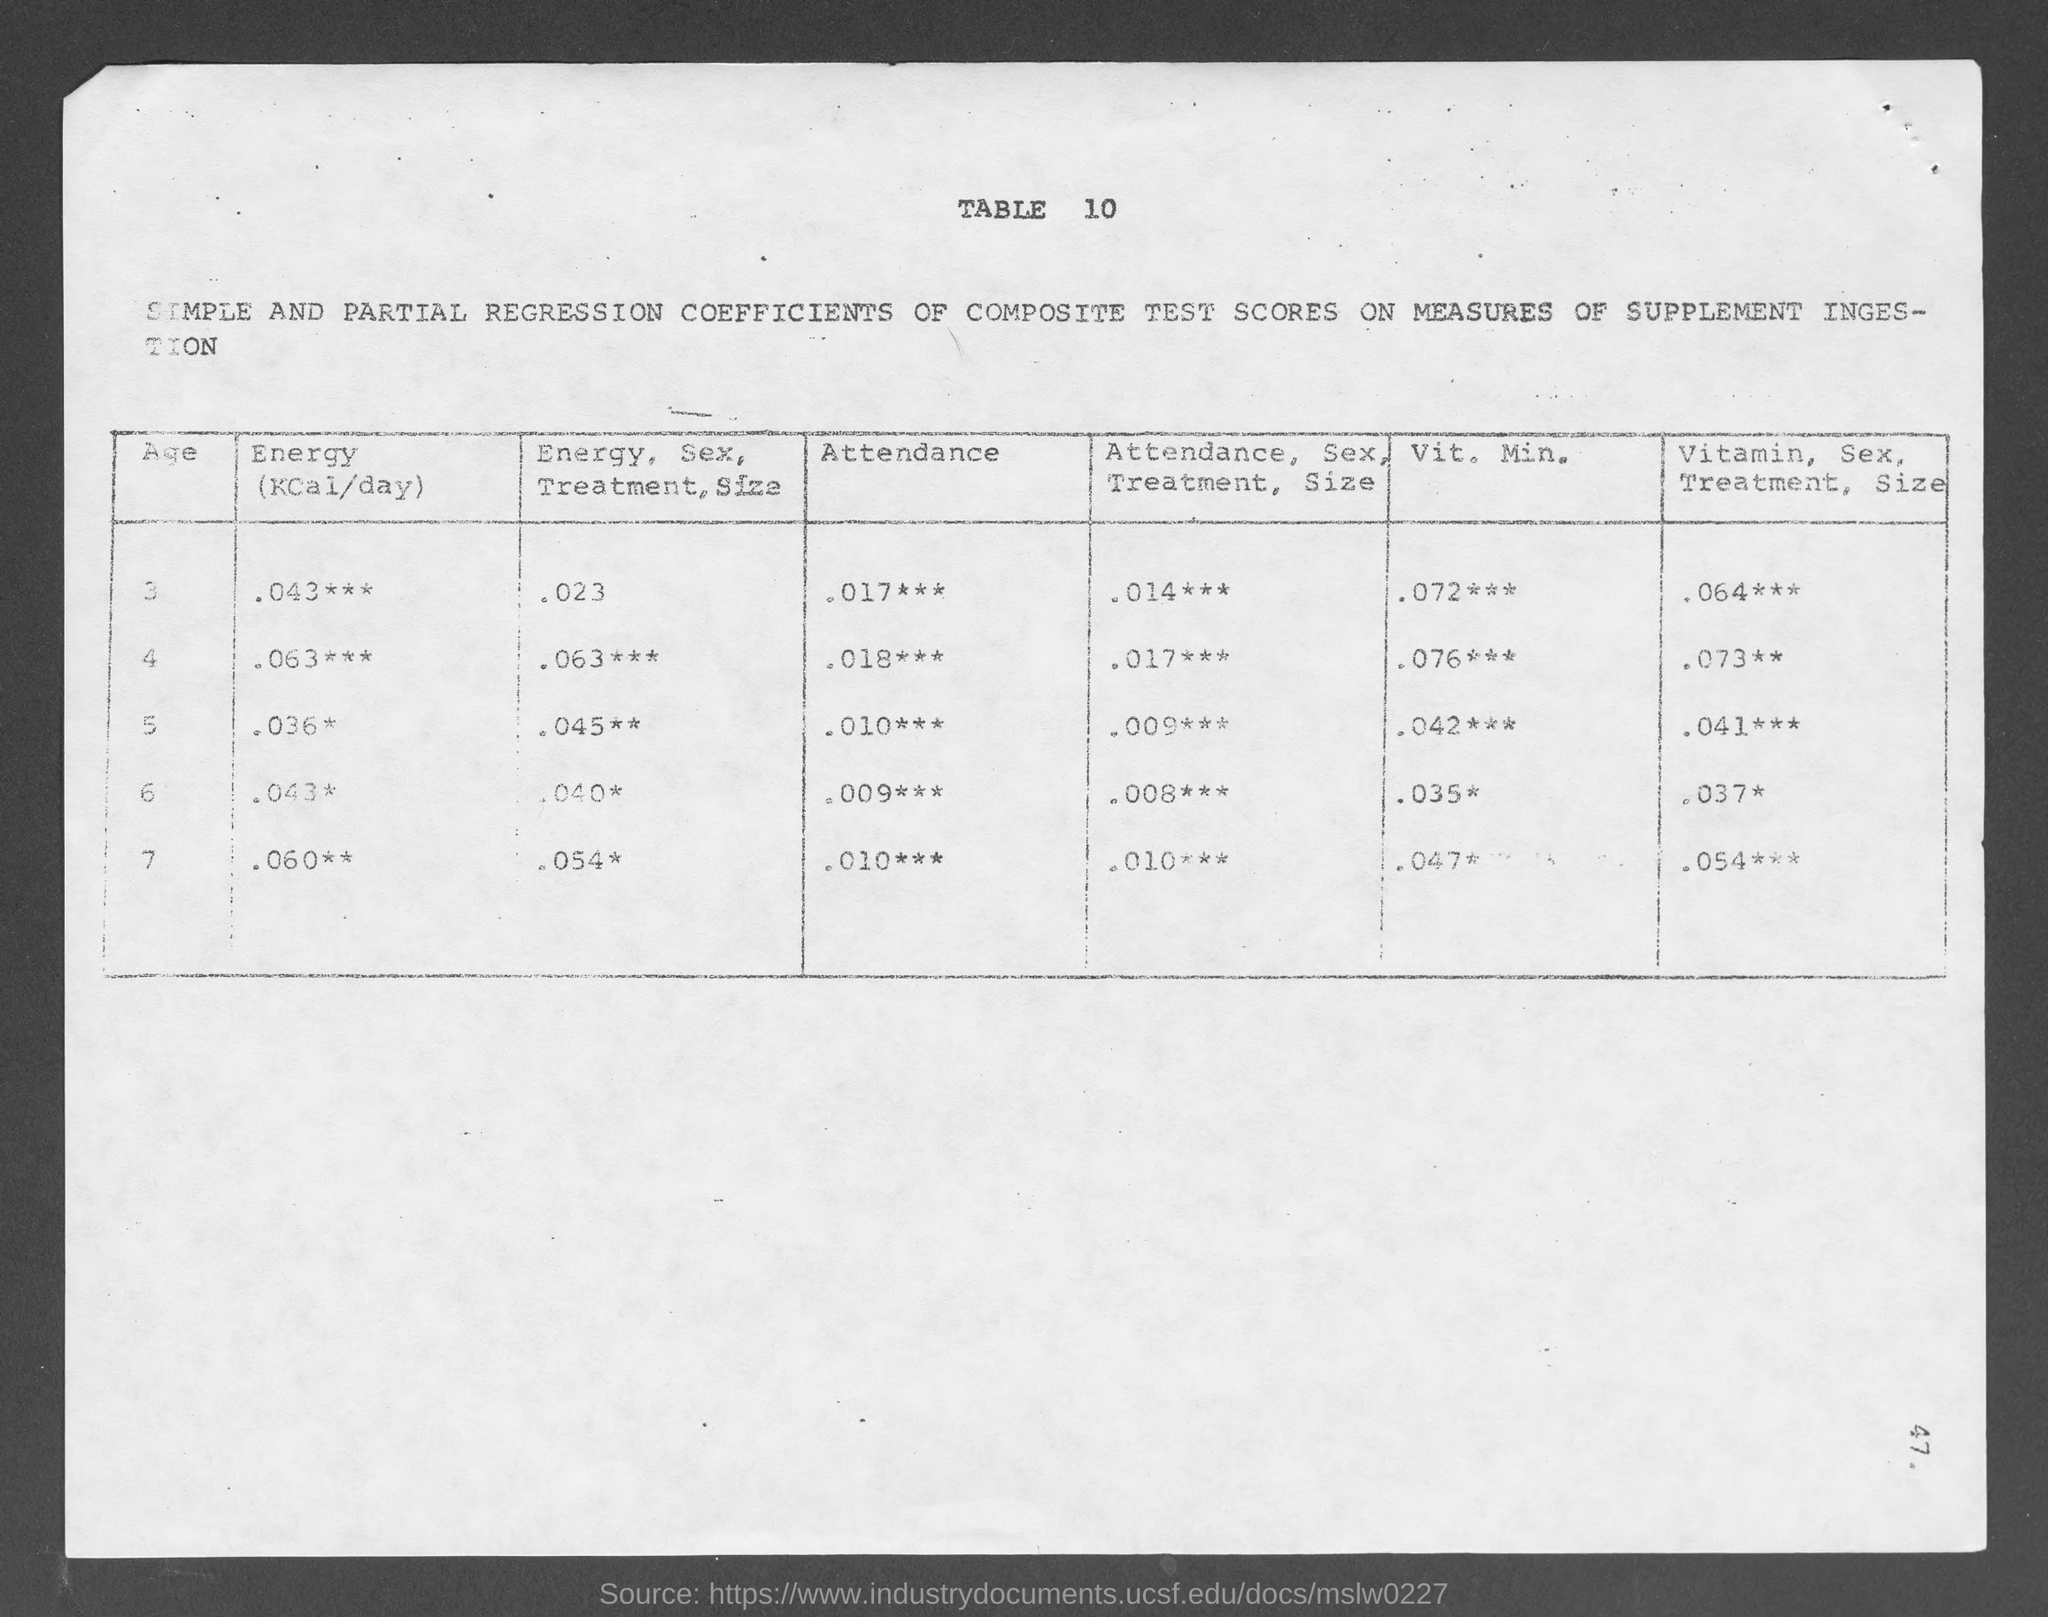Could you describe what kind of study might use this table? This table could be from an epidemiological study or a clinical trial where researchers are assessing the impact of nutritional interventions—perhaps a specific vitamin or energy supplement—on various outcomes. The table shows the relationship between these treatments and outcomes like attendance and vitamin mineral levels in participants, controlling for different variables like sex and size. 